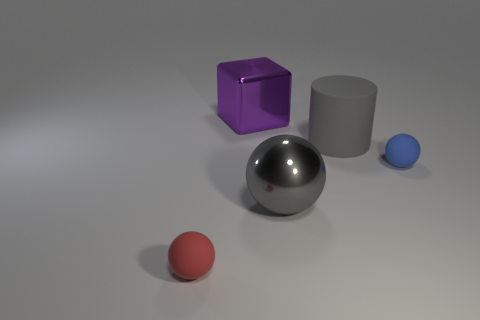Add 4 balls. How many objects exist? 9 Subtract all balls. How many objects are left? 2 Subtract all small blue objects. Subtract all large matte cylinders. How many objects are left? 3 Add 2 big spheres. How many big spheres are left? 3 Add 4 rubber cubes. How many rubber cubes exist? 4 Subtract 0 purple cylinders. How many objects are left? 5 